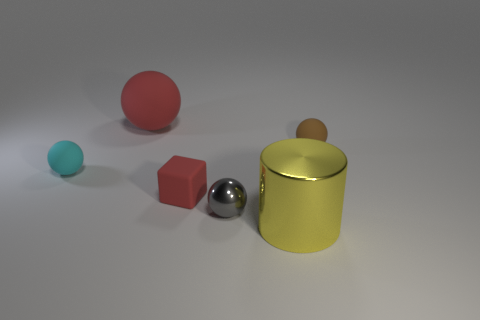Subtract all small gray shiny spheres. How many spheres are left? 3 Subtract 2 balls. How many balls are left? 2 Subtract all red balls. How many balls are left? 3 Add 3 cyan spheres. How many objects exist? 9 Subtract all cyan balls. Subtract all red cylinders. How many balls are left? 3 Subtract all cylinders. How many objects are left? 5 Subtract all small blue blocks. Subtract all large yellow objects. How many objects are left? 5 Add 6 large metallic cylinders. How many large metallic cylinders are left? 7 Add 1 rubber spheres. How many rubber spheres exist? 4 Subtract 0 blue spheres. How many objects are left? 6 